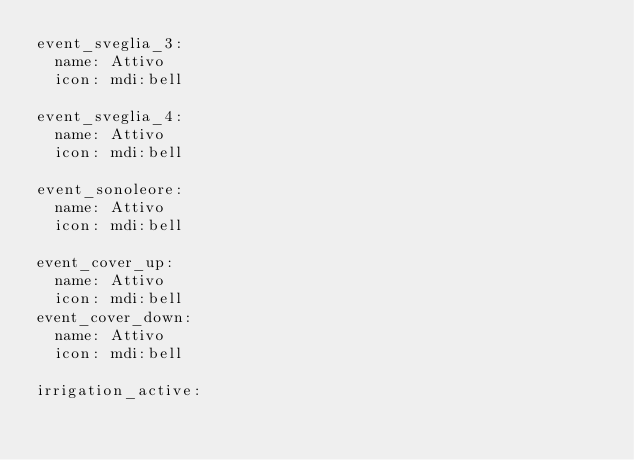<code> <loc_0><loc_0><loc_500><loc_500><_YAML_>event_sveglia_3:
  name: Attivo
  icon: mdi:bell

event_sveglia_4:
  name: Attivo
  icon: mdi:bell

event_sonoleore:
  name: Attivo
  icon: mdi:bell

event_cover_up:
  name: Attivo
  icon: mdi:bell
event_cover_down:
  name: Attivo
  icon: mdi:bell

irrigation_active:</code> 